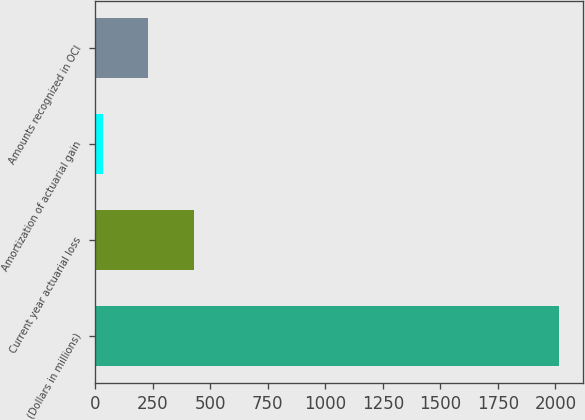<chart> <loc_0><loc_0><loc_500><loc_500><bar_chart><fcel>(Dollars in millions)<fcel>Current year actuarial loss<fcel>Amortization of actuarial gain<fcel>Amounts recognized in OCI<nl><fcel>2017<fcel>430.6<fcel>34<fcel>232.3<nl></chart> 